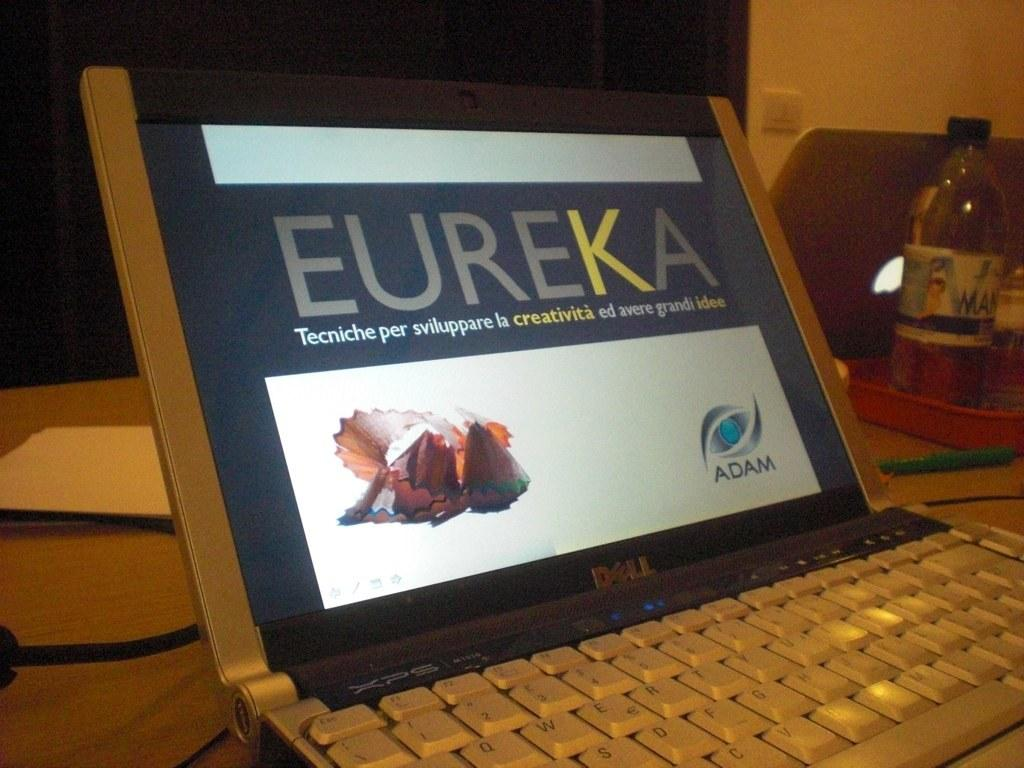<image>
Share a concise interpretation of the image provided. A monitor with the work "Eureka" on it. 